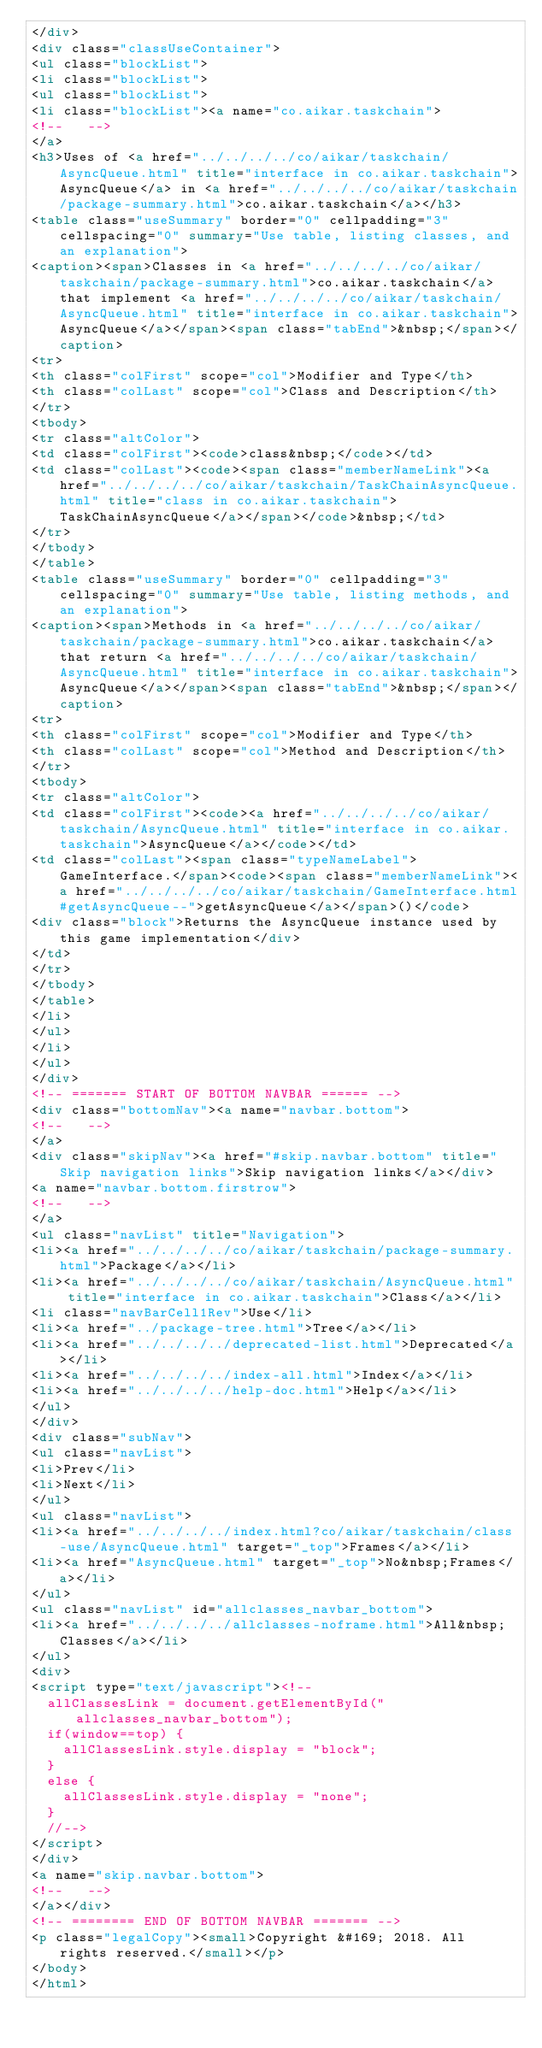<code> <loc_0><loc_0><loc_500><loc_500><_HTML_></div>
<div class="classUseContainer">
<ul class="blockList">
<li class="blockList">
<ul class="blockList">
<li class="blockList"><a name="co.aikar.taskchain">
<!--   -->
</a>
<h3>Uses of <a href="../../../../co/aikar/taskchain/AsyncQueue.html" title="interface in co.aikar.taskchain">AsyncQueue</a> in <a href="../../../../co/aikar/taskchain/package-summary.html">co.aikar.taskchain</a></h3>
<table class="useSummary" border="0" cellpadding="3" cellspacing="0" summary="Use table, listing classes, and an explanation">
<caption><span>Classes in <a href="../../../../co/aikar/taskchain/package-summary.html">co.aikar.taskchain</a> that implement <a href="../../../../co/aikar/taskchain/AsyncQueue.html" title="interface in co.aikar.taskchain">AsyncQueue</a></span><span class="tabEnd">&nbsp;</span></caption>
<tr>
<th class="colFirst" scope="col">Modifier and Type</th>
<th class="colLast" scope="col">Class and Description</th>
</tr>
<tbody>
<tr class="altColor">
<td class="colFirst"><code>class&nbsp;</code></td>
<td class="colLast"><code><span class="memberNameLink"><a href="../../../../co/aikar/taskchain/TaskChainAsyncQueue.html" title="class in co.aikar.taskchain">TaskChainAsyncQueue</a></span></code>&nbsp;</td>
</tr>
</tbody>
</table>
<table class="useSummary" border="0" cellpadding="3" cellspacing="0" summary="Use table, listing methods, and an explanation">
<caption><span>Methods in <a href="../../../../co/aikar/taskchain/package-summary.html">co.aikar.taskchain</a> that return <a href="../../../../co/aikar/taskchain/AsyncQueue.html" title="interface in co.aikar.taskchain">AsyncQueue</a></span><span class="tabEnd">&nbsp;</span></caption>
<tr>
<th class="colFirst" scope="col">Modifier and Type</th>
<th class="colLast" scope="col">Method and Description</th>
</tr>
<tbody>
<tr class="altColor">
<td class="colFirst"><code><a href="../../../../co/aikar/taskchain/AsyncQueue.html" title="interface in co.aikar.taskchain">AsyncQueue</a></code></td>
<td class="colLast"><span class="typeNameLabel">GameInterface.</span><code><span class="memberNameLink"><a href="../../../../co/aikar/taskchain/GameInterface.html#getAsyncQueue--">getAsyncQueue</a></span>()</code>
<div class="block">Returns the AsyncQueue instance used by this game implementation</div>
</td>
</tr>
</tbody>
</table>
</li>
</ul>
</li>
</ul>
</div>
<!-- ======= START OF BOTTOM NAVBAR ====== -->
<div class="bottomNav"><a name="navbar.bottom">
<!--   -->
</a>
<div class="skipNav"><a href="#skip.navbar.bottom" title="Skip navigation links">Skip navigation links</a></div>
<a name="navbar.bottom.firstrow">
<!--   -->
</a>
<ul class="navList" title="Navigation">
<li><a href="../../../../co/aikar/taskchain/package-summary.html">Package</a></li>
<li><a href="../../../../co/aikar/taskchain/AsyncQueue.html" title="interface in co.aikar.taskchain">Class</a></li>
<li class="navBarCell1Rev">Use</li>
<li><a href="../package-tree.html">Tree</a></li>
<li><a href="../../../../deprecated-list.html">Deprecated</a></li>
<li><a href="../../../../index-all.html">Index</a></li>
<li><a href="../../../../help-doc.html">Help</a></li>
</ul>
</div>
<div class="subNav">
<ul class="navList">
<li>Prev</li>
<li>Next</li>
</ul>
<ul class="navList">
<li><a href="../../../../index.html?co/aikar/taskchain/class-use/AsyncQueue.html" target="_top">Frames</a></li>
<li><a href="AsyncQueue.html" target="_top">No&nbsp;Frames</a></li>
</ul>
<ul class="navList" id="allclasses_navbar_bottom">
<li><a href="../../../../allclasses-noframe.html">All&nbsp;Classes</a></li>
</ul>
<div>
<script type="text/javascript"><!--
  allClassesLink = document.getElementById("allclasses_navbar_bottom");
  if(window==top) {
    allClassesLink.style.display = "block";
  }
  else {
    allClassesLink.style.display = "none";
  }
  //-->
</script>
</div>
<a name="skip.navbar.bottom">
<!--   -->
</a></div>
<!-- ======== END OF BOTTOM NAVBAR ======= -->
<p class="legalCopy"><small>Copyright &#169; 2018. All rights reserved.</small></p>
</body>
</html>
</code> 